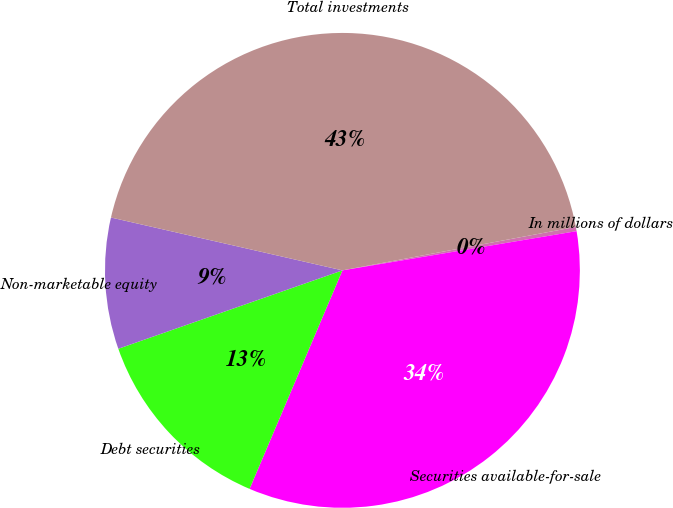Convert chart. <chart><loc_0><loc_0><loc_500><loc_500><pie_chart><fcel>In millions of dollars<fcel>Securities available-for-sale<fcel>Debt securities<fcel>Non-marketable equity<fcel>Total investments<nl><fcel>0.29%<fcel>34.04%<fcel>13.25%<fcel>8.93%<fcel>43.5%<nl></chart> 